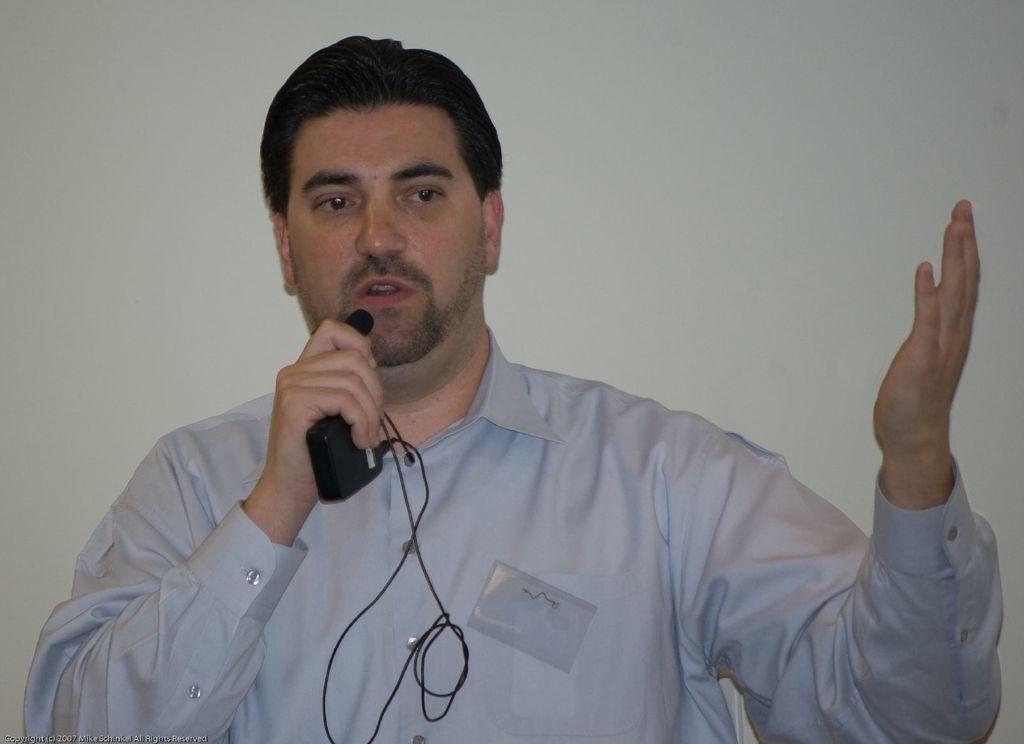Please provide a concise description of this image. In this image there is a white color shirt man holding a mike in his hand ,and speaking in mike ,and back ground there is a wall. 